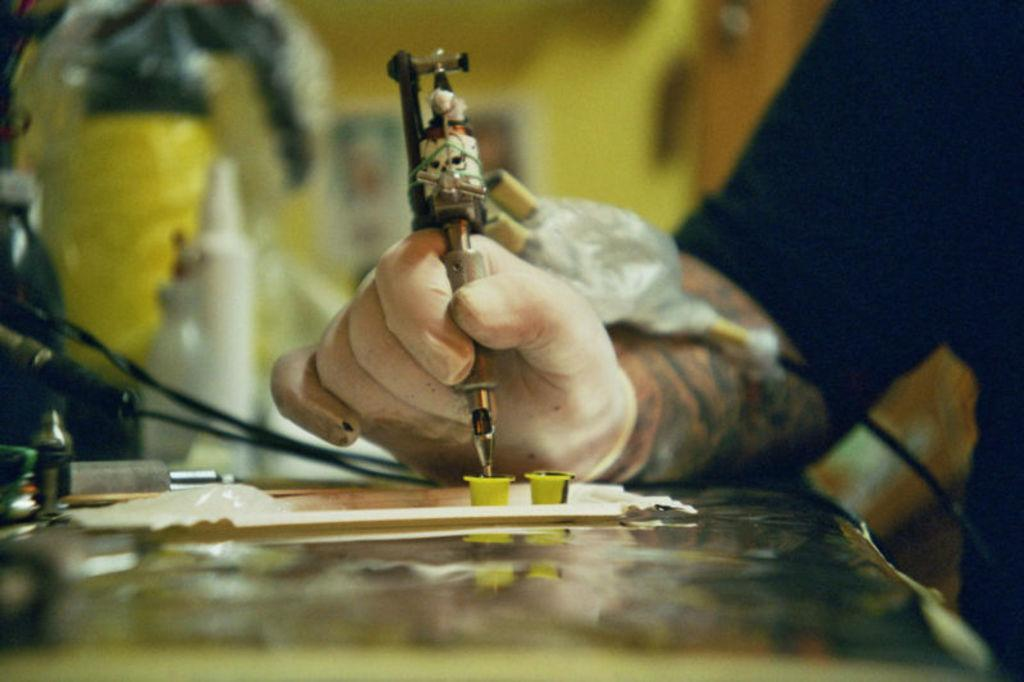What is the person's hand holding in the image? There is a person's hand holding an object in the image. What is the person doing with the other object on the table? The person is working on another object on a table. What type of items can be seen on the table? There are cables visible on the table, as well as other objects. What type of roof can be seen in the image? There is no roof visible in the image; it is focused on a person's hand and objects on a table. 